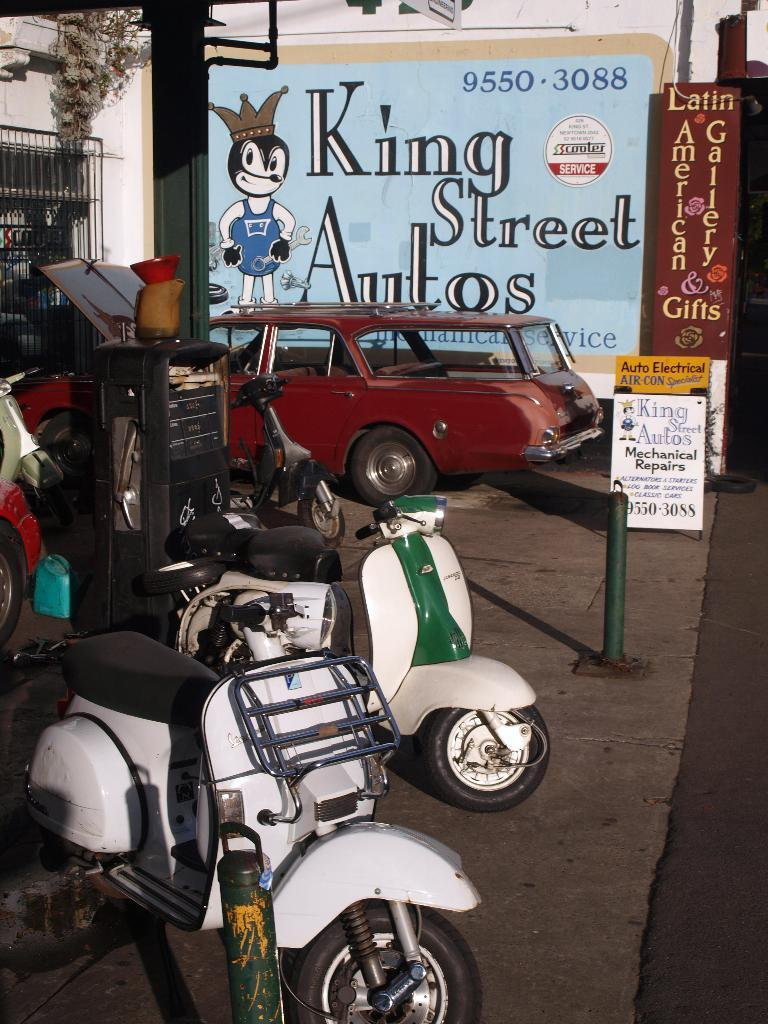What type of vehicles are present in the image? There are bi-cycles and cars in the image. What else can be seen in the image besides vehicles? There is a board, text, a window, and creepers visible in the image. Where is the text located in the image? The text is visible in the middle of the image. What might be used for displaying information or messages in the image? The board in the image might be used for displaying information or messages. What type of calculator is being used by the fireman in the image? There is no calculator or fireman present in the image. 